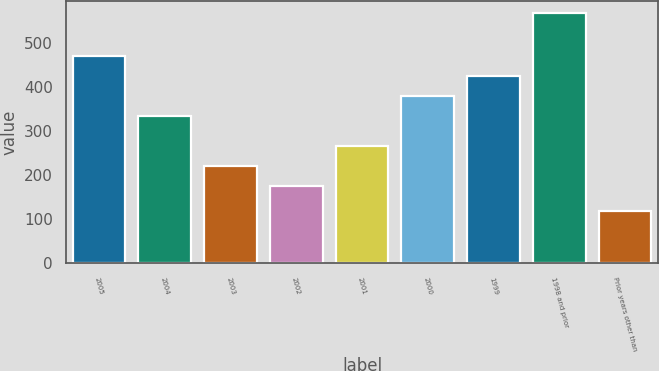Convert chart. <chart><loc_0><loc_0><loc_500><loc_500><bar_chart><fcel>2005<fcel>2004<fcel>2003<fcel>2002<fcel>2001<fcel>2000<fcel>1999<fcel>1998 and prior<fcel>Prior years other than<nl><fcel>469.7<fcel>335<fcel>220.9<fcel>176<fcel>265.8<fcel>379.9<fcel>424.8<fcel>567<fcel>118<nl></chart> 